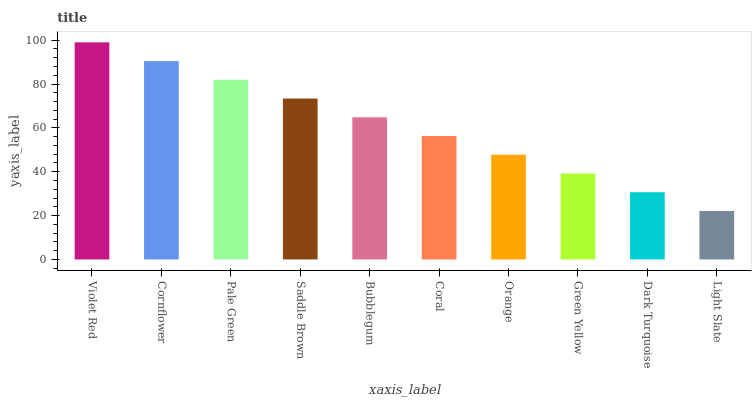Is Light Slate the minimum?
Answer yes or no. Yes. Is Violet Red the maximum?
Answer yes or no. Yes. Is Cornflower the minimum?
Answer yes or no. No. Is Cornflower the maximum?
Answer yes or no. No. Is Violet Red greater than Cornflower?
Answer yes or no. Yes. Is Cornflower less than Violet Red?
Answer yes or no. Yes. Is Cornflower greater than Violet Red?
Answer yes or no. No. Is Violet Red less than Cornflower?
Answer yes or no. No. Is Bubblegum the high median?
Answer yes or no. Yes. Is Coral the low median?
Answer yes or no. Yes. Is Saddle Brown the high median?
Answer yes or no. No. Is Light Slate the low median?
Answer yes or no. No. 